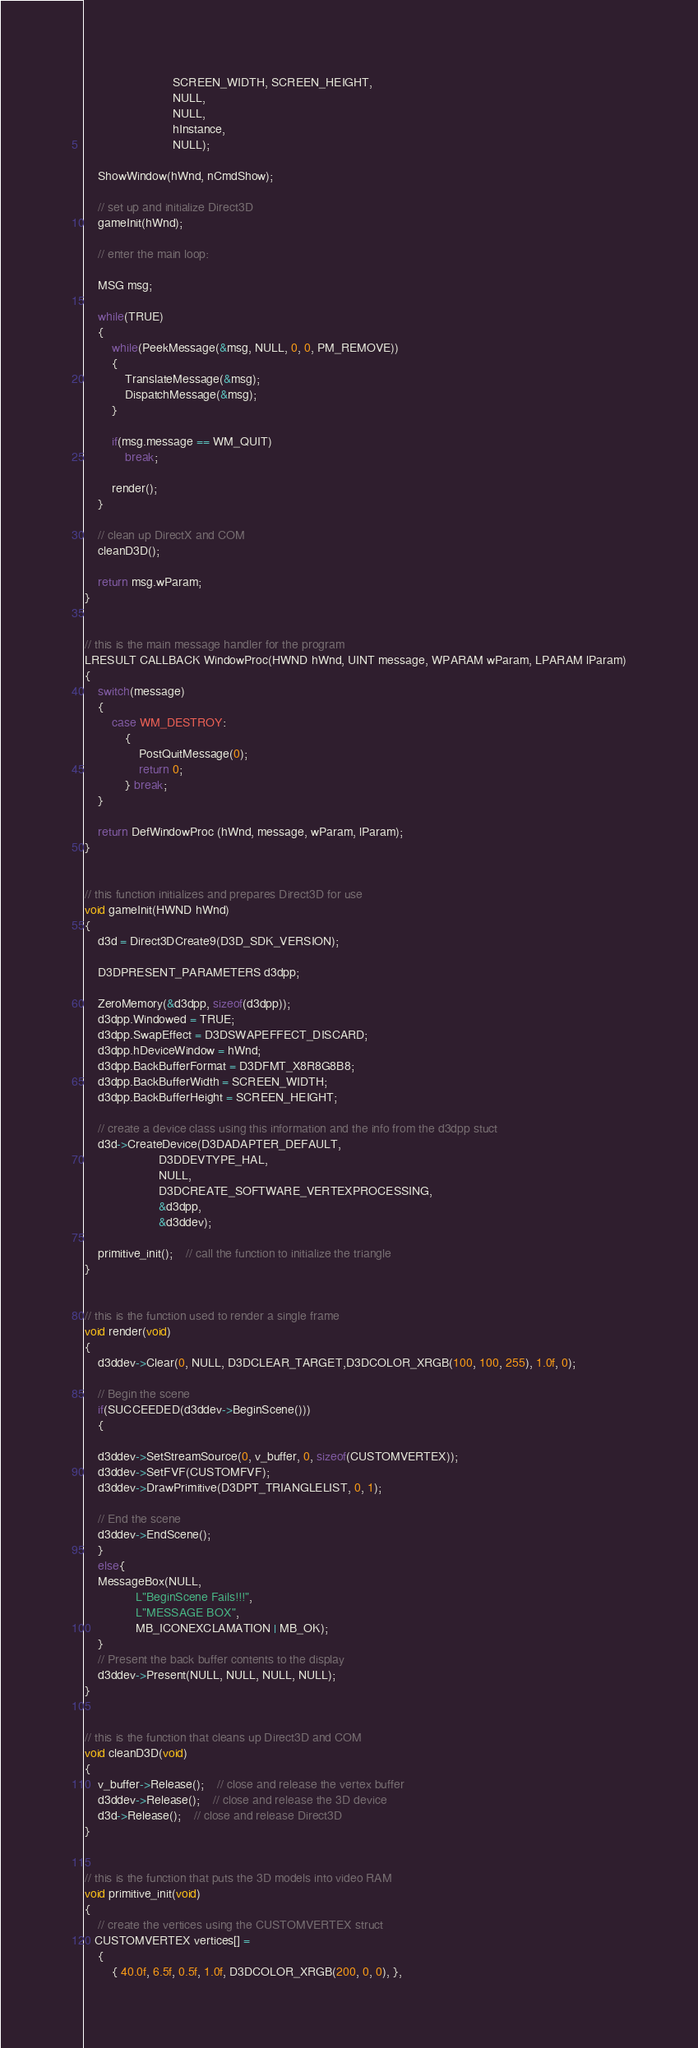<code> <loc_0><loc_0><loc_500><loc_500><_C++_>                          SCREEN_WIDTH, SCREEN_HEIGHT,
                          NULL,
                          NULL,
                          hInstance,
                          NULL);

    ShowWindow(hWnd, nCmdShow);

    // set up and initialize Direct3D
    gameInit(hWnd);

    // enter the main loop:

    MSG msg;

    while(TRUE)
    {
        while(PeekMessage(&msg, NULL, 0, 0, PM_REMOVE))
        {
            TranslateMessage(&msg);
            DispatchMessage(&msg);
        }

        if(msg.message == WM_QUIT)
            break;

        render();
    }

    // clean up DirectX and COM
    cleanD3D();

    return msg.wParam;
}


// this is the main message handler for the program
LRESULT CALLBACK WindowProc(HWND hWnd, UINT message, WPARAM wParam, LPARAM lParam)
{
    switch(message)
    {
        case WM_DESTROY:
            {
                PostQuitMessage(0);
                return 0;
            } break;
    }

    return DefWindowProc (hWnd, message, wParam, lParam);
}


// this function initializes and prepares Direct3D for use
void gameInit(HWND hWnd)
{
    d3d = Direct3DCreate9(D3D_SDK_VERSION);

    D3DPRESENT_PARAMETERS d3dpp;

    ZeroMemory(&d3dpp, sizeof(d3dpp));
    d3dpp.Windowed = TRUE;
    d3dpp.SwapEffect = D3DSWAPEFFECT_DISCARD;
    d3dpp.hDeviceWindow = hWnd;
    d3dpp.BackBufferFormat = D3DFMT_X8R8G8B8;
    d3dpp.BackBufferWidth = SCREEN_WIDTH;
    d3dpp.BackBufferHeight = SCREEN_HEIGHT;

    // create a device class using this information and the info from the d3dpp stuct
    d3d->CreateDevice(D3DADAPTER_DEFAULT,
                      D3DDEVTYPE_HAL,
                      NULL,
                      D3DCREATE_SOFTWARE_VERTEXPROCESSING,
                      &d3dpp,
                      &d3ddev);

    primitive_init();    // call the function to initialize the triangle
}


// this is the function used to render a single frame
void render(void)
{
	d3ddev->Clear(0, NULL, D3DCLEAR_TARGET,D3DCOLOR_XRGB(100, 100, 255), 1.0f, 0);	

	// Begin the scene
	if(SUCCEEDED(d3ddev->BeginScene()))
	{

	d3ddev->SetStreamSource(0, v_buffer, 0, sizeof(CUSTOMVERTEX));
	d3ddev->SetFVF(CUSTOMFVF);
	d3ddev->DrawPrimitive(D3DPT_TRIANGLELIST, 0, 1);

	// End the scene
	d3ddev->EndScene();
	}
	else{
	MessageBox(NULL,
               L"BeginScene Fails!!!",
               L"MESSAGE BOX",
               MB_ICONEXCLAMATION | MB_OK);
	}
	// Present the back buffer contents to the display
	d3ddev->Present(NULL, NULL, NULL, NULL);
}


// this is the function that cleans up Direct3D and COM
void cleanD3D(void)
{
    v_buffer->Release();    // close and release the vertex buffer
    d3ddev->Release();    // close and release the 3D device
    d3d->Release();    // close and release Direct3D
}


// this is the function that puts the 3D models into video RAM
void primitive_init(void)
{
    // create the vertices using the CUSTOMVERTEX struct
   CUSTOMVERTEX vertices[] =
    {
        { 40.0f, 6.5f, 0.5f, 1.0f, D3DCOLOR_XRGB(200, 0, 0), },</code> 